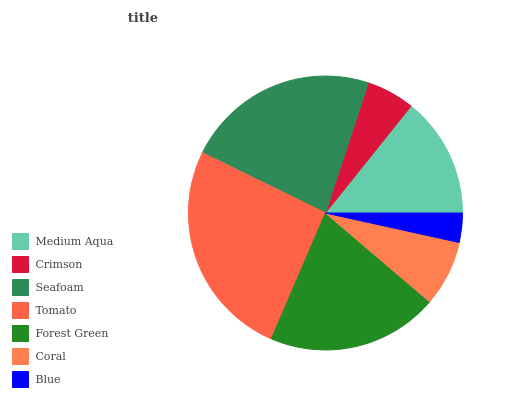Is Blue the minimum?
Answer yes or no. Yes. Is Tomato the maximum?
Answer yes or no. Yes. Is Crimson the minimum?
Answer yes or no. No. Is Crimson the maximum?
Answer yes or no. No. Is Medium Aqua greater than Crimson?
Answer yes or no. Yes. Is Crimson less than Medium Aqua?
Answer yes or no. Yes. Is Crimson greater than Medium Aqua?
Answer yes or no. No. Is Medium Aqua less than Crimson?
Answer yes or no. No. Is Medium Aqua the high median?
Answer yes or no. Yes. Is Medium Aqua the low median?
Answer yes or no. Yes. Is Tomato the high median?
Answer yes or no. No. Is Coral the low median?
Answer yes or no. No. 